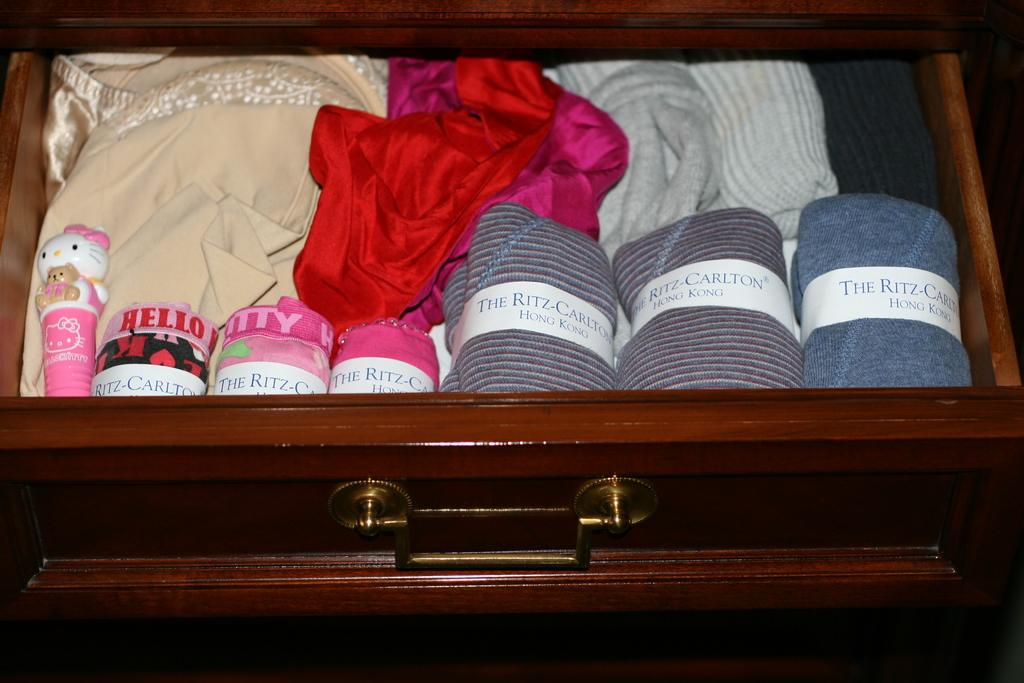<image>
Offer a succinct explanation of the picture presented. A sock drawer with some socks from The Ritz Carlton Hong Kong. 